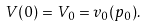<formula> <loc_0><loc_0><loc_500><loc_500>V ( 0 ) = V _ { 0 } = v _ { 0 } ( p _ { 0 } ) .</formula> 